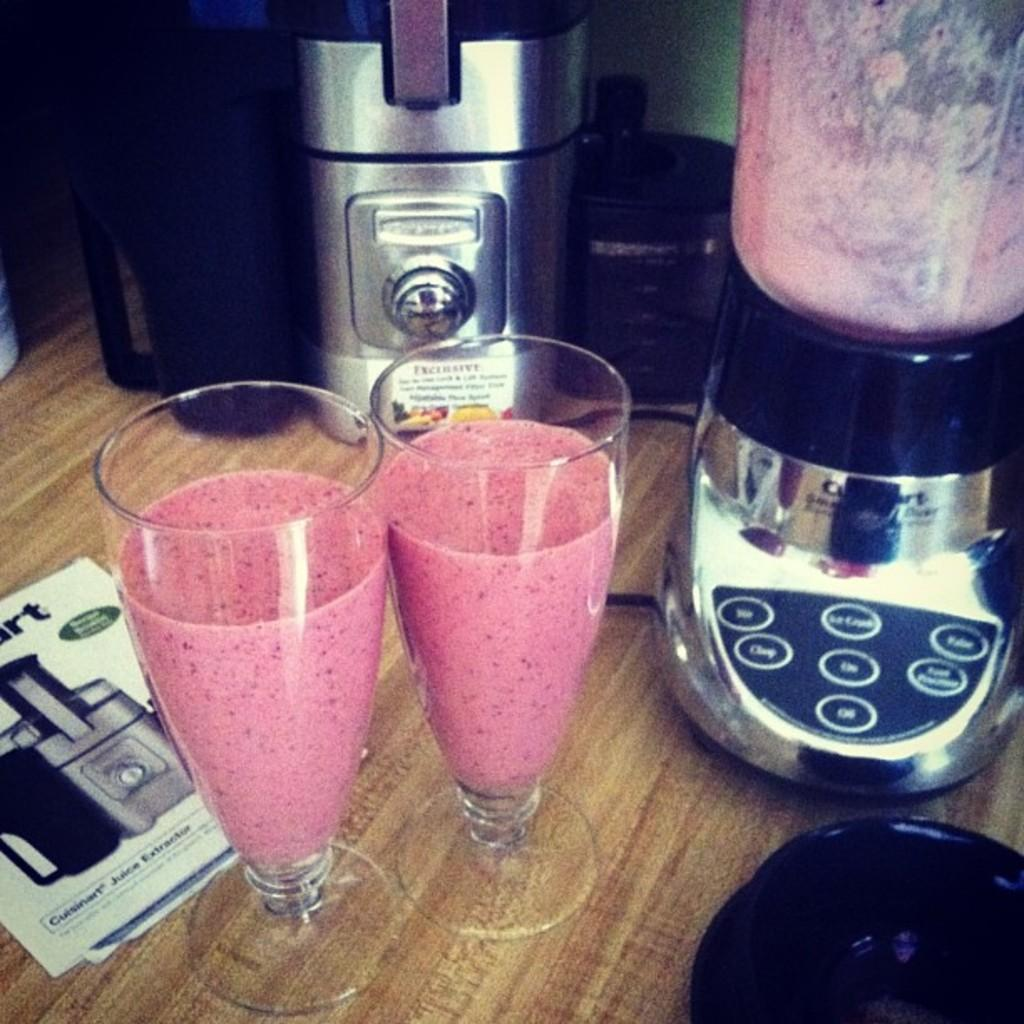<image>
Present a compact description of the photo's key features. Two smoothies are on a table next to a Cuisinart juice extractor. 